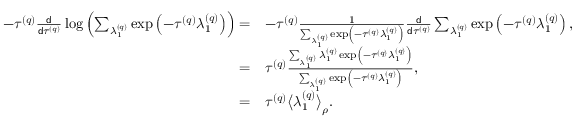Convert formula to latex. <formula><loc_0><loc_0><loc_500><loc_500>\begin{array} { r l } { - \tau ^ { \left ( q \right ) } \frac { d } { d \tau ^ { \left ( q \right ) } } \log \left ( \sum _ { \lambda _ { 1 } ^ { \left ( q \right ) } } \exp \left ( - \tau ^ { \left ( q \right ) } \lambda _ { 1 } ^ { \left ( q \right ) } \right ) \right ) = } & { - \tau ^ { \left ( q \right ) } \frac { 1 } { \sum _ { \lambda _ { 1 } ^ { \left ( q \right ) } } \exp \left ( - \tau ^ { \left ( q \right ) } \lambda _ { 1 } ^ { \left ( q \right ) } \right ) } \frac { d } { d \tau ^ { \left ( q \right ) } } \sum _ { \lambda _ { 1 } ^ { \left ( q \right ) } } \exp \left ( - \tau ^ { \left ( q \right ) } \lambda _ { 1 } ^ { \left ( q \right ) } \right ) , } \\ { = } & { \tau ^ { \left ( q \right ) } \frac { \sum _ { \lambda _ { 1 } ^ { \left ( q \right ) } } \lambda _ { 1 } ^ { \left ( q \right ) } \exp \left ( - \tau ^ { \left ( q \right ) } \lambda _ { 1 } ^ { \left ( q \right ) } \right ) } { \sum _ { \lambda _ { 1 } ^ { \left ( q \right ) } } \exp \left ( - \tau ^ { \left ( q \right ) } \lambda _ { 1 } ^ { \left ( q \right ) } \right ) } , } \\ { = } & { \tau ^ { \left ( q \right ) } \left \langle \lambda _ { 1 } ^ { \left ( q \right ) } \right \rangle _ { \rho } . } \end{array}</formula> 